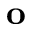Convert formula to latex. <formula><loc_0><loc_0><loc_500><loc_500>o</formula> 